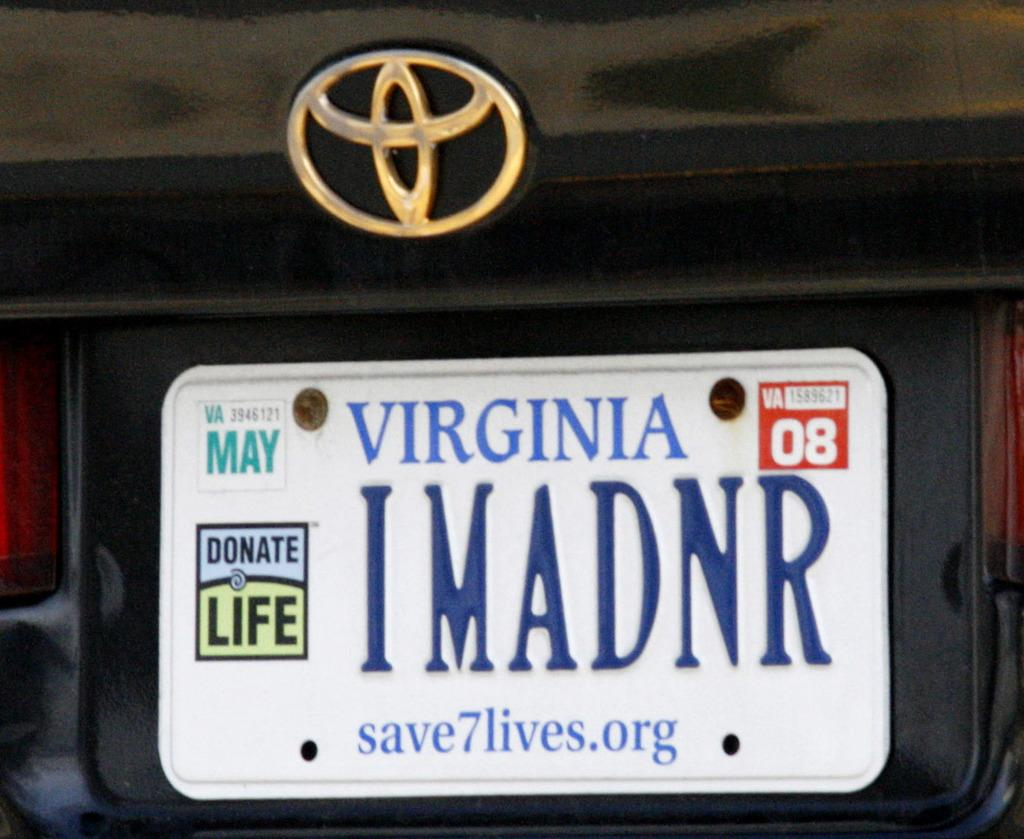<image>
Create a compact narrative representing the image presented. Back of a Toyota vehicle that has a Virginia License plate, which expires May 08 and has the text IMADNR, save 7 lives.org, Donate Life. 